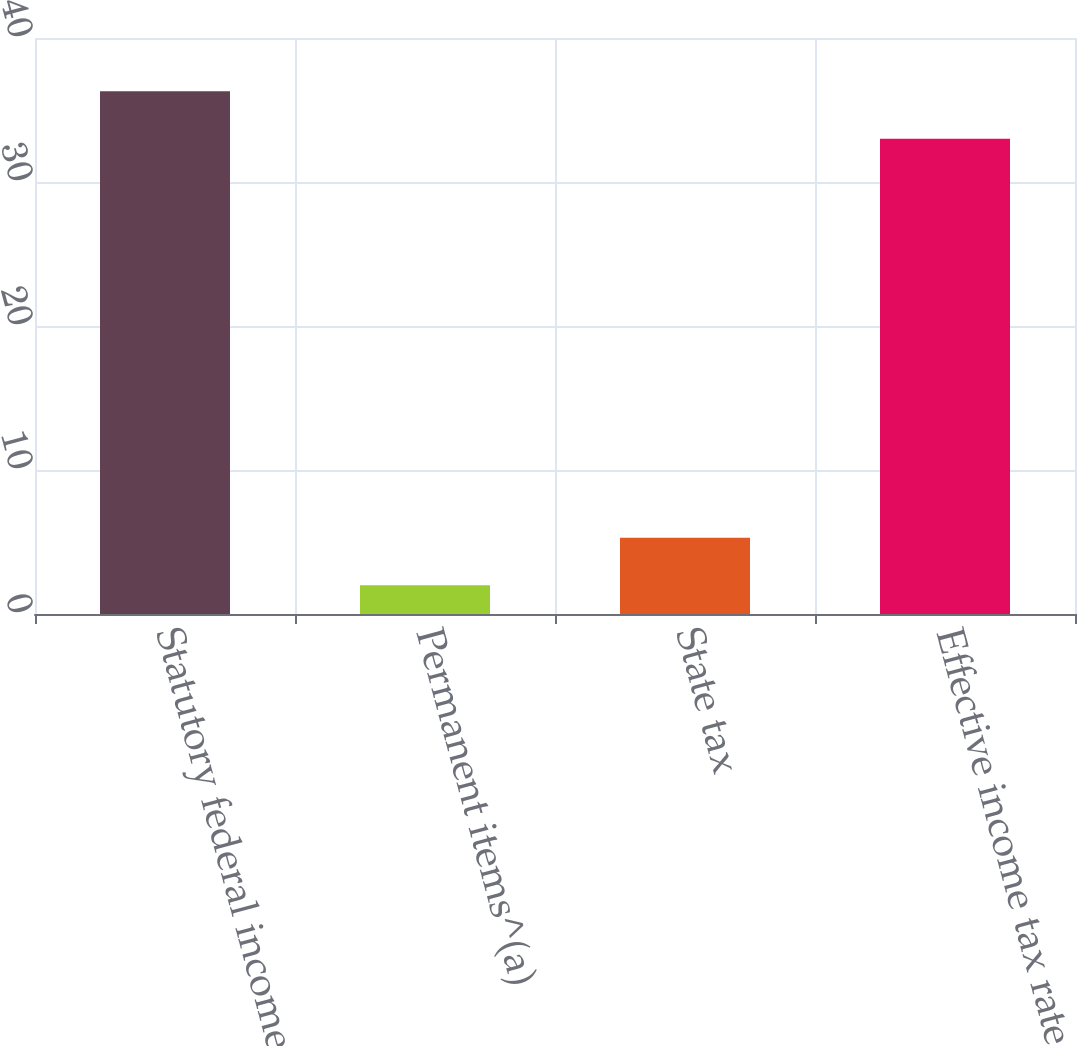Convert chart. <chart><loc_0><loc_0><loc_500><loc_500><bar_chart><fcel>Statutory federal income tax<fcel>Permanent items^(a)<fcel>State tax<fcel>Effective income tax rate<nl><fcel>36.3<fcel>2<fcel>5.3<fcel>33<nl></chart> 